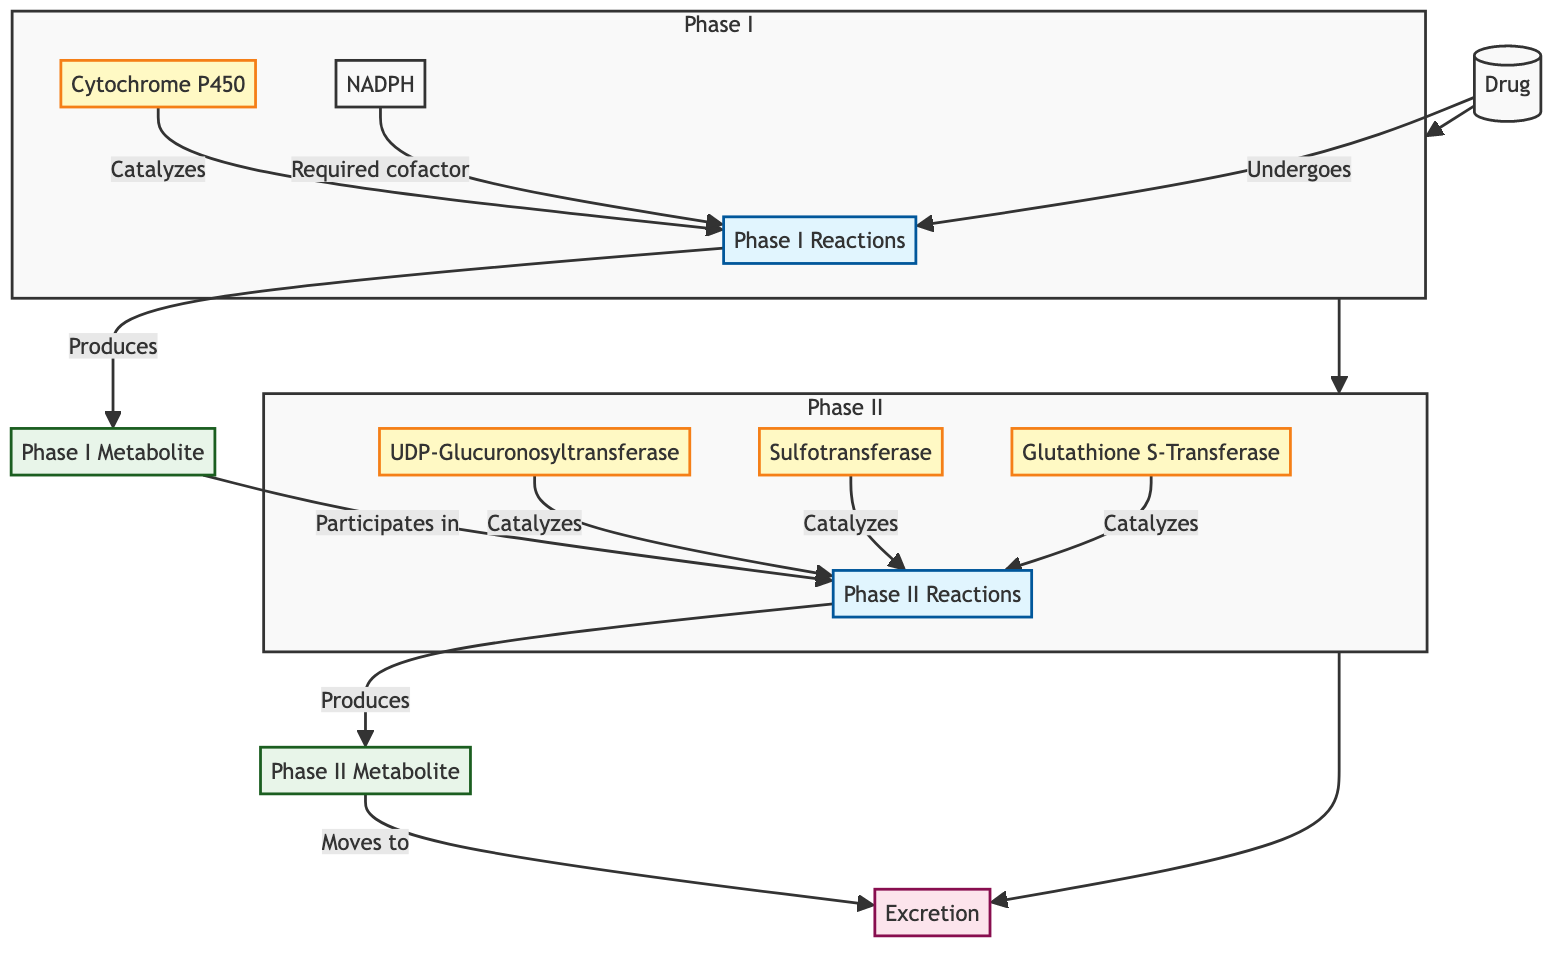What are the two main phases of drug metabolism? The diagram clearly labels two phases involved in drug metabolism: Phase I and Phase II. These are distinct processes that lead to the transformation of the drug as it is metabolized.
Answer: Phase I and Phase II Which enzyme catalyzes the Phase I reactions? In the diagram, Cytochrome P450 is indicated as the enzyme responsible for catalyzing Phase I reactions. This is a critical point within the Phase I section of the diagram.
Answer: Cytochrome P450 What is produced after Phase I reactions? The diagram shows that after Phase I reactions, Phase I Metabolite is produced. This is clearly documented as the output of the Phase I section.
Answer: Phase I Metabolite How many enzymes are involved in Phase II reactions? The diagram displays three enzymes involved in Phase II reactions: UDP-Glucuronosyltransferase, Sulfotransferase, and Glutathione S-Transferase. By directly counting these listed enzymes in the Phase II section of the diagram, we determine the total number.
Answer: 3 What is required as a cofactor for Phase I reactions? The diagram specifies that NADPH is a required cofactor for Phase I reactions. This critical detail is shown along the connection labeled as "Required cofactor" in the Phase I section.
Answer: NADPH What happens to the Phase II Metabolite after it is produced? According to the diagram, the Phase II Metabolite is shown to move toward Excretion after its production. This indicates the final step of the metabolism pathway.
Answer: Moves to Excretion Which phase comes after Phase I in drug metabolism? The diagram indicates that Phase II follows Phase I in the order of drug metabolism. This sequence is illustrated clearly in the flow of the diagram.
Answer: Phase II What is the relationship between the Phase IMetabolite and Phase II? The diagram shows an arrow indicating that the Phase I Metabolite participates in Phase II reactions, establishing a direct relationship between these two phases of metabolism.
Answer: Participates in Phase II What are the three enzymes listed in Phase II? The diagram lists three enzymes involved in Phase II reactions: UDP-Glucuronosyltransferase, Sulfotransferase, and Glutathione S-Transferase. These are shown with clear labels.
Answer: UGT, SULT, GST 